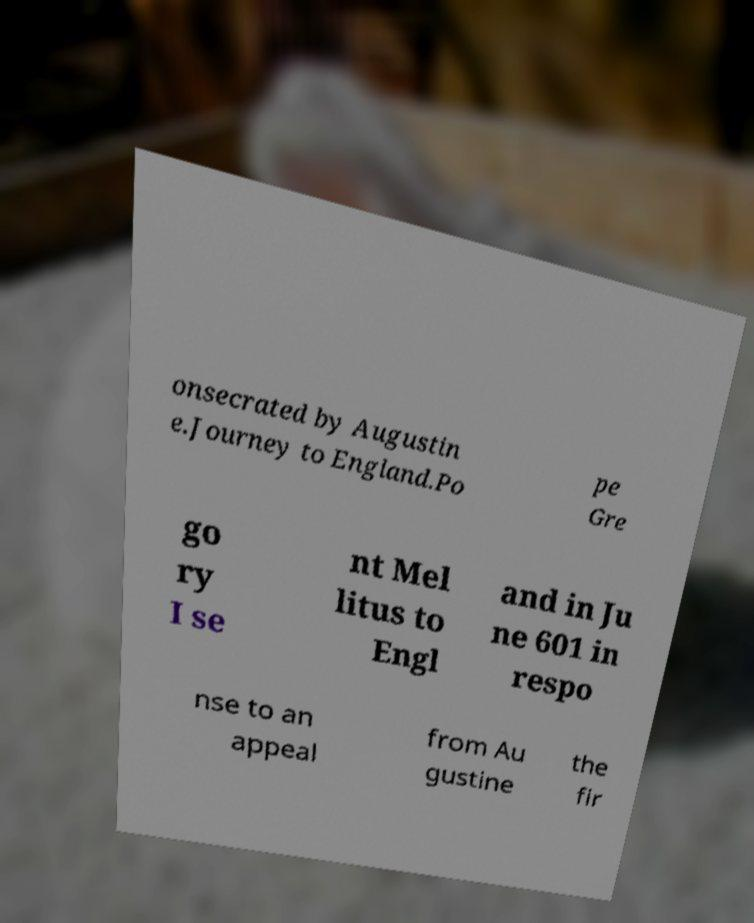There's text embedded in this image that I need extracted. Can you transcribe it verbatim? onsecrated by Augustin e.Journey to England.Po pe Gre go ry I se nt Mel litus to Engl and in Ju ne 601 in respo nse to an appeal from Au gustine the fir 